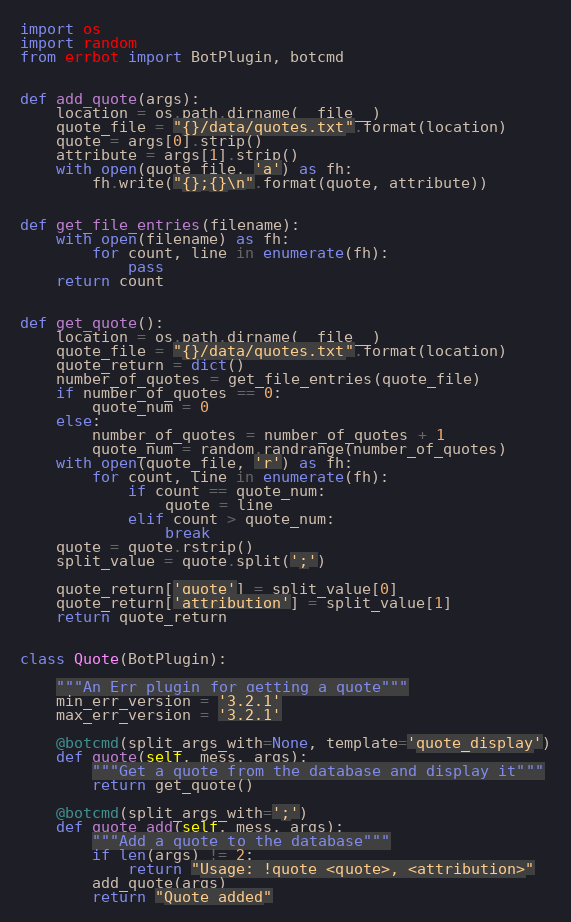Convert code to text. <code><loc_0><loc_0><loc_500><loc_500><_Python_>import os
import random
from errbot import BotPlugin, botcmd


def add_quote(args):
    location = os.path.dirname(__file__)
    quote_file = "{}/data/quotes.txt".format(location)
    quote = args[0].strip()
    attribute = args[1].strip()
    with open(quote_file, 'a') as fh:
        fh.write("{};{}\n".format(quote, attribute))


def get_file_entries(filename):
    with open(filename) as fh:
        for count, line in enumerate(fh):
            pass
    return count


def get_quote():
    location = os.path.dirname(__file__)
    quote_file = "{}/data/quotes.txt".format(location)
    quote_return = dict()
    number_of_quotes = get_file_entries(quote_file)
    if number_of_quotes == 0:
        quote_num = 0
    else:
        number_of_quotes = number_of_quotes + 1
        quote_num = random.randrange(number_of_quotes)
    with open(quote_file, 'r') as fh:
        for count, line in enumerate(fh):
            if count == quote_num:
                quote = line
            elif count > quote_num:
                break
    quote = quote.rstrip()
    split_value = quote.split(';')

    quote_return['quote'] = split_value[0]
    quote_return['attribution'] = split_value[1]
    return quote_return


class Quote(BotPlugin):

    """An Err plugin for getting a quote"""
    min_err_version = '3.2.1'
    max_err_version = '3.2.1'

    @botcmd(split_args_with=None, template='quote_display')
    def quote(self, mess, args):
        """Get a quote from the database and display it"""
        return get_quote()

    @botcmd(split_args_with=';')
    def quote_add(self, mess, args):
        """Add a quote to the database"""
        if len(args) != 2:
            return "Usage: !quote <quote>, <attribution>"
        add_quote(args)
        return "Quote added"
</code> 